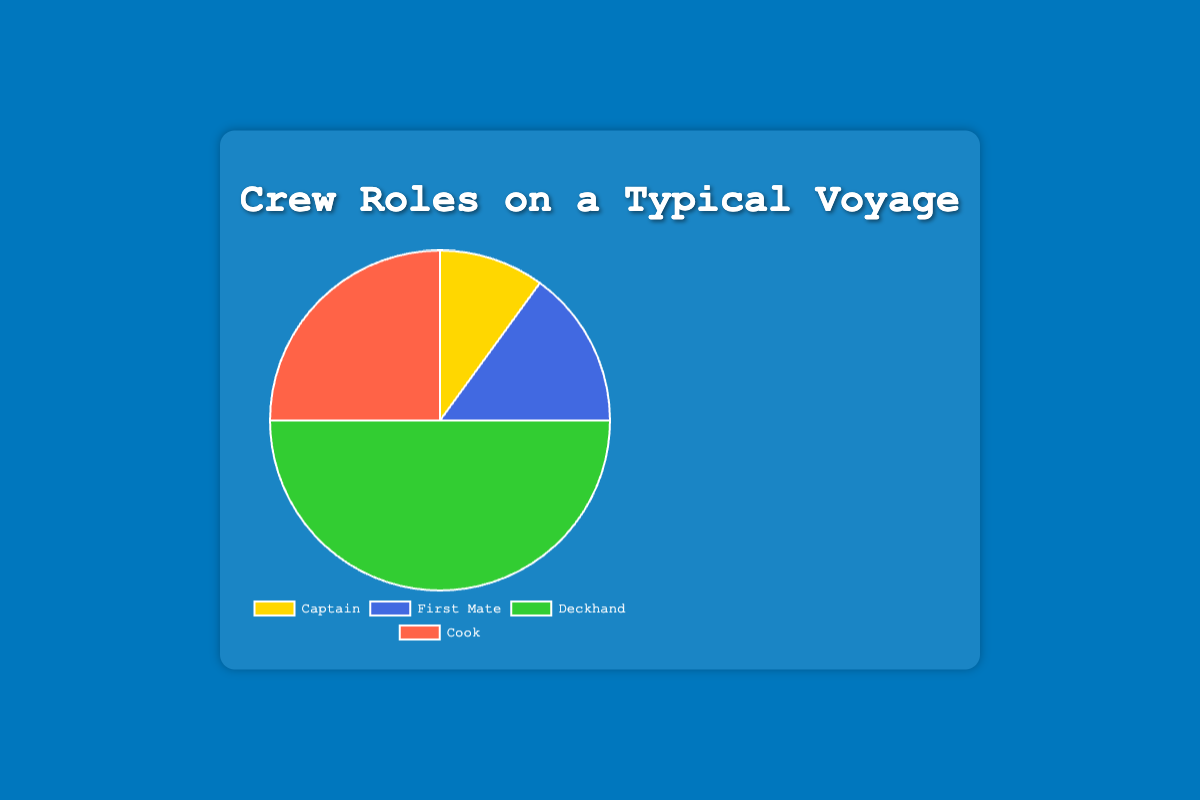Which crew role has the largest percentage on a typical voyage? The deckhand role covers 50% of the crew, which is the largest percentage as seen in the pie chart.
Answer: Deckhand What is the combined percentage of the Captain and First Mate roles? By adding the percentages of the Captain (10%) and the First Mate (15%), you get 25%.
Answer: 25 How does the percentage of the Cook compare to the First Mate? The percentage of the Cook (25%) is 10% higher than the First Mate (15%).
Answer: 10% higher What role represents a quarter of the crew? The Cook represents 25% of the crew, which is one quarter.
Answer: Cook What percentage difference is there between the Deckhands and the total of Captain and First Mate? The Deckhands constitute 50% of the crew. The combined percentage of Captain and First Mate is 25%. The difference is 50% - 25% = 25%.
Answer: 25% Which color represents the Cook's percentage in the pie chart? The Cook's percentage of 25% is represented by a red-colored section of the pie chart.
Answer: Red If you combined the percentages of the Captain and the Cook, would the total be greater than the Deckhands' percentage? The combined percentages of the Captain (10%) and the Cook (25%) is 35%, which is less than the Deckhands' 50%.
Answer: No What is the combined total percentage of the roles other than the Deckhands? Adding up the percentages of Captain (10%), First Mate (15%), and Cook (25%) gives 50%, which is the total for all roles other than Deckhands.
Answer: 50 How many times larger is the percentage of Deckhands than the Captain's percentage? The Deckhands’ percentage (50%) is 5 times larger than the Captain’s percentage (10%).
Answer: 5 times 